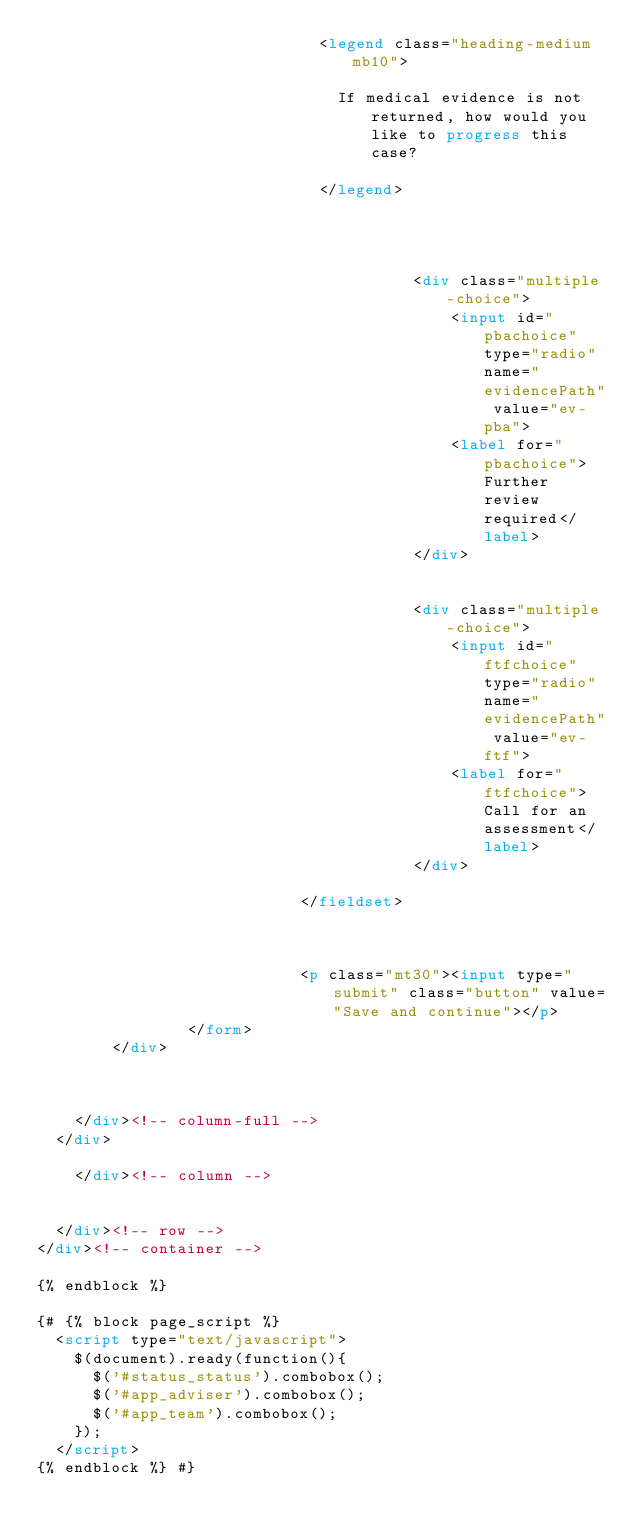Convert code to text. <code><loc_0><loc_0><loc_500><loc_500><_HTML_>							  <legend class="heading-medium mb10">

								If medical evidence is not returned, how would you like to progress this case?

							  </legend>




										<div class="multiple-choice">
											<input id="pbachoice" type="radio" name="evidencePath" value="ev-pba">
											<label for="pbachoice">Further review required</label>
										</div>


										<div class="multiple-choice">
											<input id="ftfchoice" type="radio" name="evidencePath" value="ev-ftf">
											<label for="ftfchoice">Call for an assessment</label>
										</div>

							</fieldset>



							<p class="mt30"><input type="submit" class="button" value="Save and continue"></p>
				</form>
		</div>



    </div><!-- column-full -->
  </div>

    </div><!-- column -->


  </div><!-- row -->
</div><!-- container -->

{% endblock %}

{# {% block page_script %}
  <script type="text/javascript">
    $(document).ready(function(){
      $('#status_status').combobox();
      $('#app_adviser').combobox();
      $('#app_team').combobox();
    });
  </script>
{% endblock %} #}
</code> 